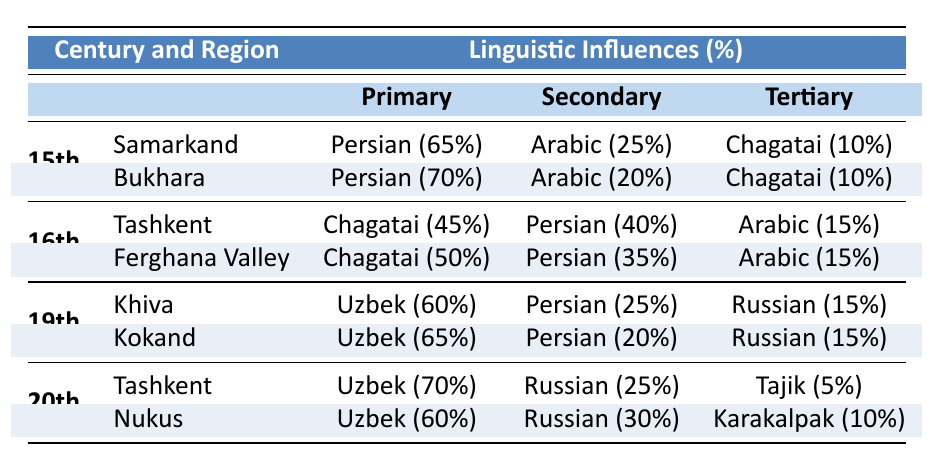What linguistic influence is predominant in Bukhara during the 15th century? In the table, Bukhara's linguistic influences show that Persian has the highest percentage at 70%.
Answer: Persian Which region has the highest influence from Chagatai in the 16th century? Tashkent has 45% influence from Chagatai, while Ferghana Valley has 50%. Therefore, Ferghana Valley has the highest influence from Chagatai.
Answer: Ferghana Valley Is the primary linguistic influence in Khiva during the 19th century Uzbek? The table shows that Uzbek is the primary language influence in Khiva at 60%.
Answer: Yes What is the secondary linguistic influence in Tashkent during the 20th century? In Tashkent, the second highest percentage of influence is from Russian, which is 25%.
Answer: Russian What is the combined percentage of Arabic and Persian influences in Samarkand in the 15th century? In Samarkand, Persian has 65% influence and Arabic has 25% influence. Adding these gives 65 + 25 = 90%.
Answer: 90% Which century shows a shift towards greater Uzbek influence in literature? Comparing the data, in the 15th century, the primary influences include Persian and Arabic, while in the 20th century, Uzbek becomes the primary influence with 70%. This indicates a shift towards greater Uzbek influence.
Answer: 20th century For which region in the 19th century is the influence of Russian the lowest? In both Khiva and Kokand, Russian influence is 15% in both regions. Thus, the Russian influence is the same in both regions and is the lowest when compared to other linguistic influences.
Answer: Both regions have the same lowest influence of 15% What percentage of linguistic influence in Tashkent during the 20th century is attributed to Tajik? The table indicates that Tajik has a 5% influence in Tashkent during the 20th century.
Answer: 5% What is the average percentage of Persian influence across all centuries listed in the table? To find the average, calculate the percentages of Persian influence: 70% (Bukhara) + 40% (Tashkent in the 16th century) + 25% (Khiva) + 20% (Kokand) + 25% (Tashkent in the 20th century) = 210%. Dividing by 5 gives an average of 42%.
Answer: 42% 